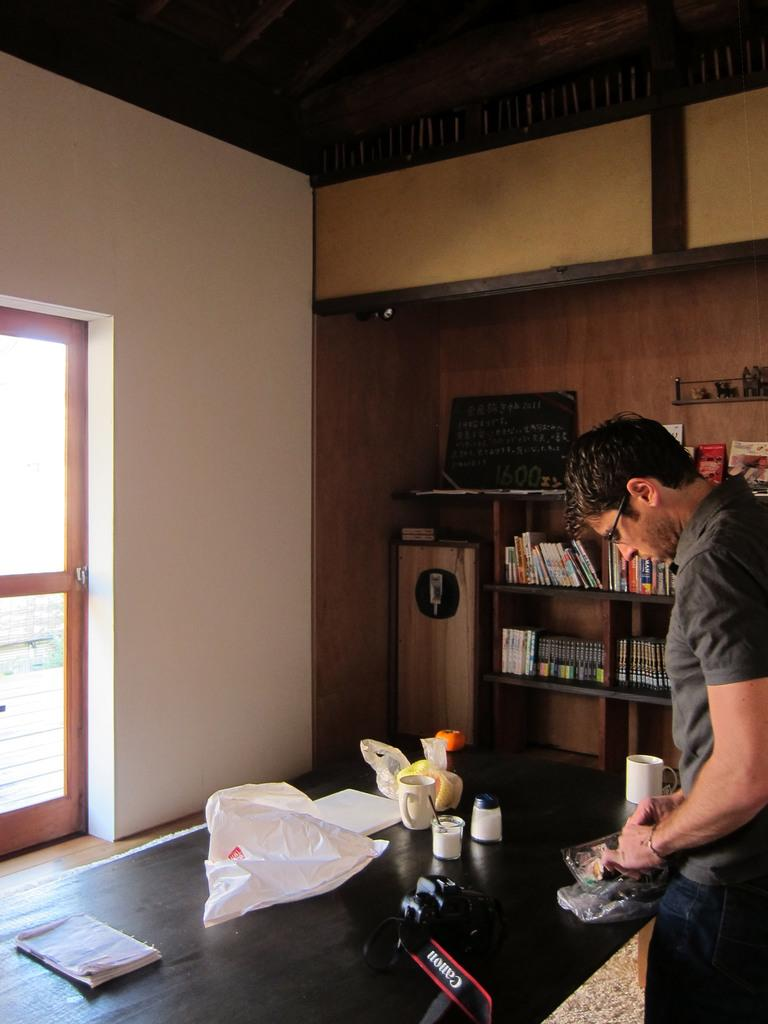<image>
Summarize the visual content of the image. a man standing behind a counter with a canon camera on it 